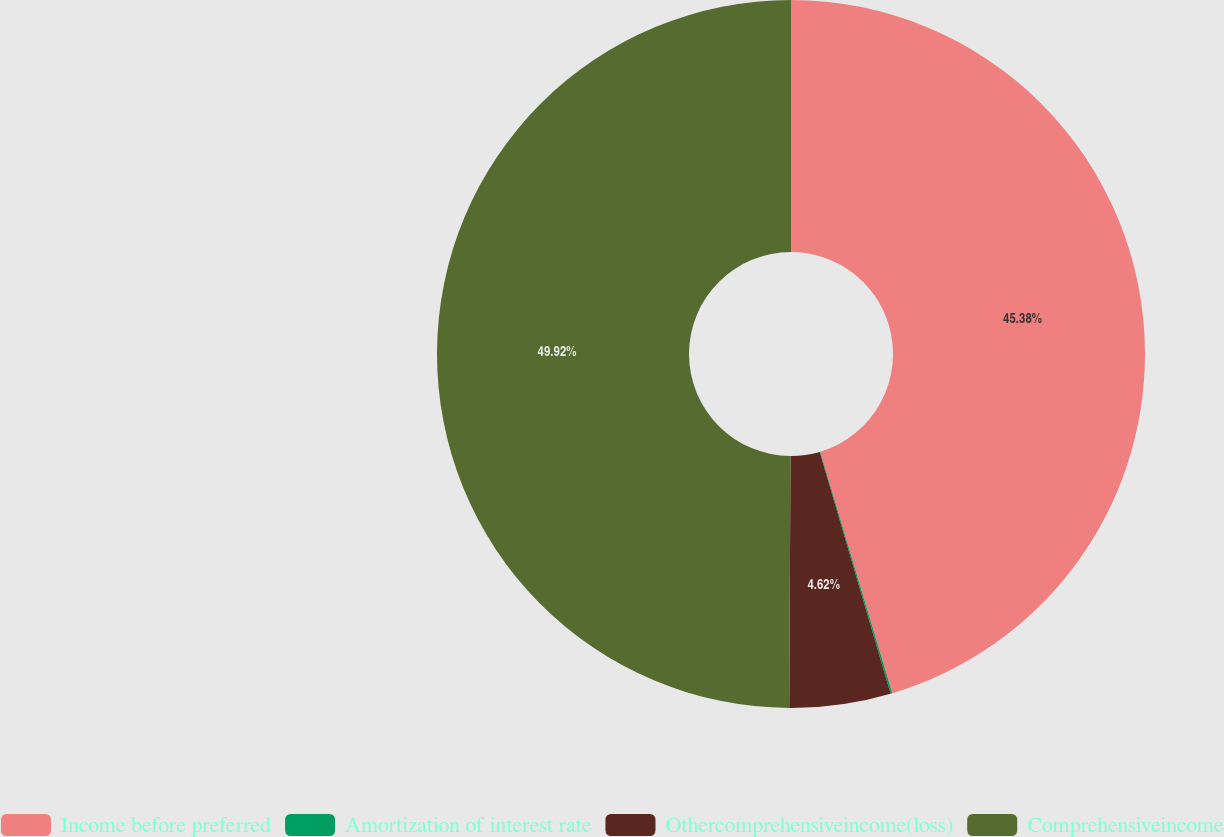Convert chart. <chart><loc_0><loc_0><loc_500><loc_500><pie_chart><fcel>Income before preferred<fcel>Amortization of interest rate<fcel>Othercomprehensiveincome(loss)<fcel>Comprehensiveincome<nl><fcel>45.38%<fcel>0.08%<fcel>4.62%<fcel>49.92%<nl></chart> 